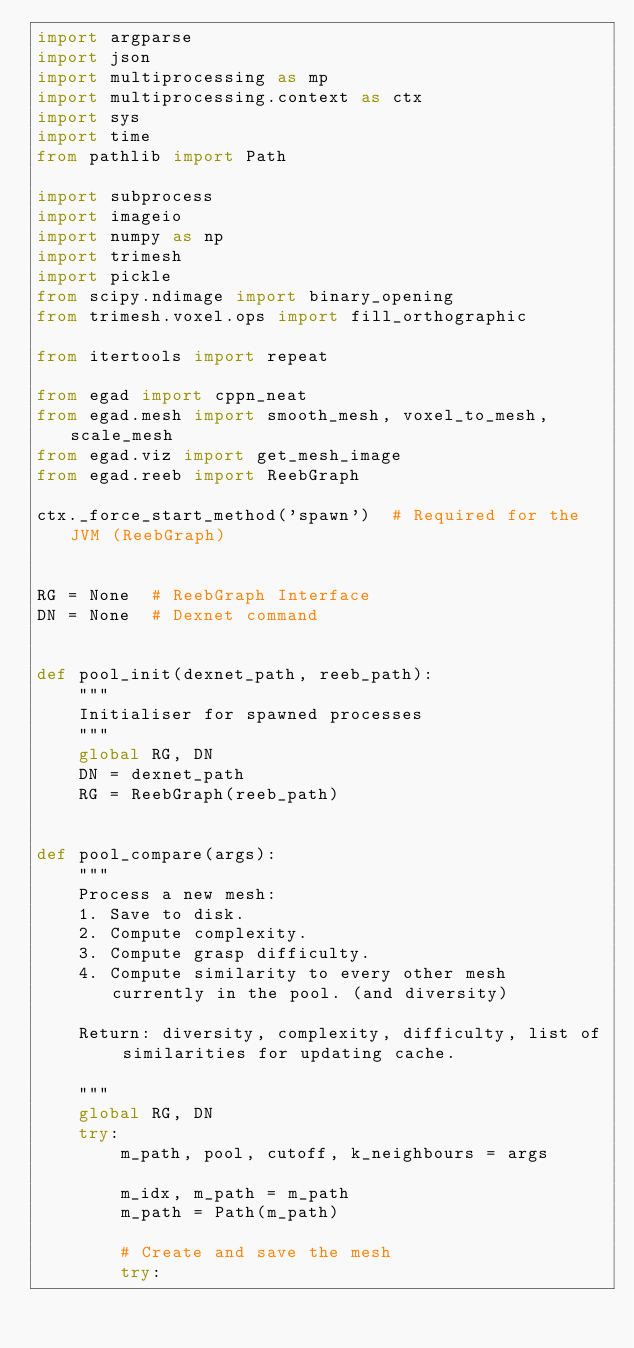Convert code to text. <code><loc_0><loc_0><loc_500><loc_500><_Python_>import argparse
import json
import multiprocessing as mp
import multiprocessing.context as ctx
import sys
import time
from pathlib import Path

import subprocess
import imageio
import numpy as np
import trimesh
import pickle
from scipy.ndimage import binary_opening
from trimesh.voxel.ops import fill_orthographic

from itertools import repeat

from egad import cppn_neat
from egad.mesh import smooth_mesh, voxel_to_mesh, scale_mesh
from egad.viz import get_mesh_image
from egad.reeb import ReebGraph

ctx._force_start_method('spawn')  # Required for the JVM (ReebGraph)


RG = None  # ReebGraph Interface
DN = None  # Dexnet command


def pool_init(dexnet_path, reeb_path):
    """
    Initialiser for spawned processes
    """
    global RG, DN
    DN = dexnet_path
    RG = ReebGraph(reeb_path)


def pool_compare(args):
    """
    Process a new mesh:
    1. Save to disk.
    2. Compute complexity.
    3. Compute grasp difficulty.
    4. Compute similarity to every other mesh currently in the pool. (and diversity)

    Return: diversity, complexity, difficulty, list of similarities for updating cache.

    """
    global RG, DN
    try:
        m_path, pool, cutoff, k_neighbours = args

        m_idx, m_path = m_path
        m_path = Path(m_path)

        # Create and save the mesh
        try:</code> 